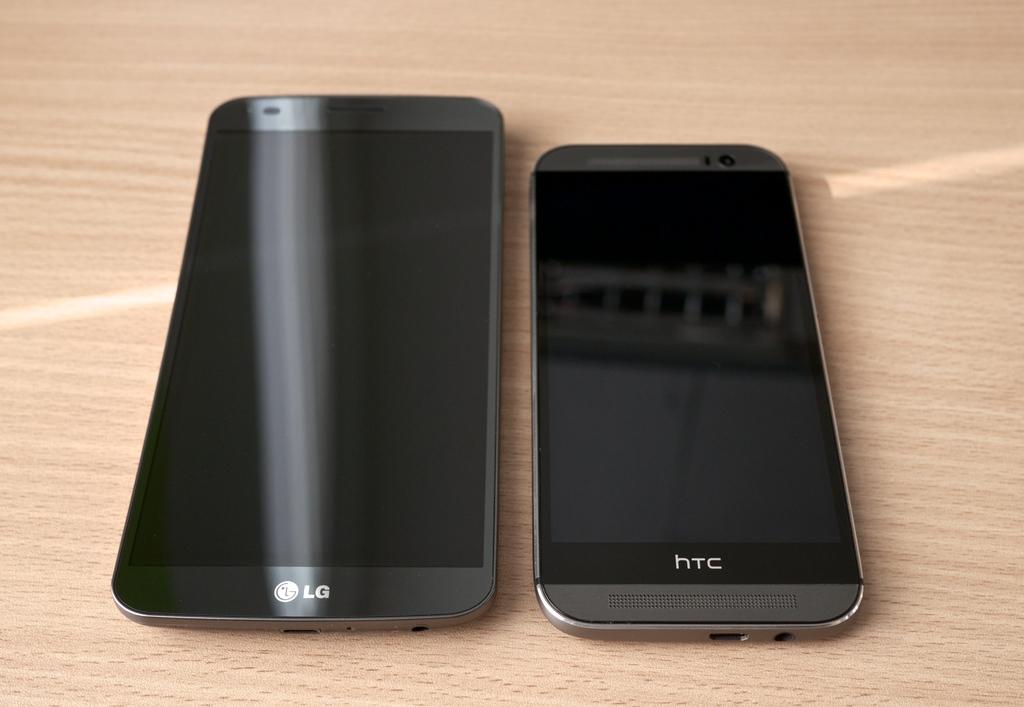What brand is the phone on the right?
Make the answer very short. Htc. Are the bottom letters on the right  htc?
Offer a very short reply. Yes. 